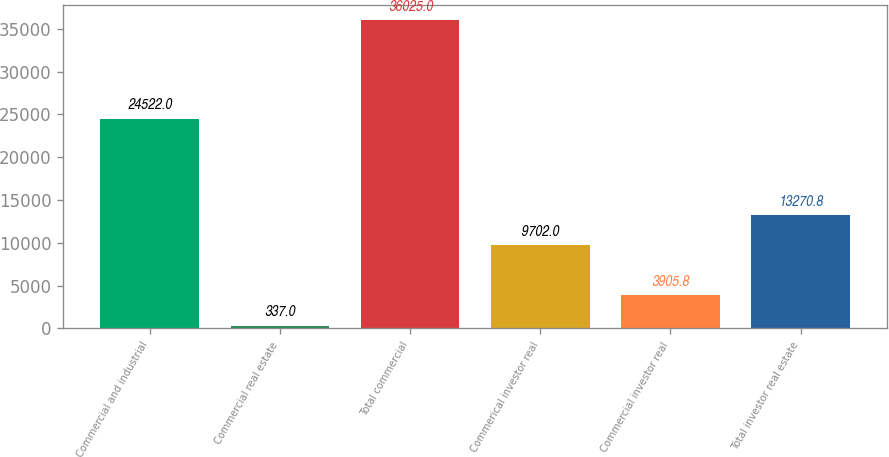Convert chart. <chart><loc_0><loc_0><loc_500><loc_500><bar_chart><fcel>Commercial and industrial<fcel>Commercial real estate<fcel>Total commercial<fcel>Commerical investor real<fcel>Commercial investor real<fcel>Total investor real estate<nl><fcel>24522<fcel>337<fcel>36025<fcel>9702<fcel>3905.8<fcel>13270.8<nl></chart> 